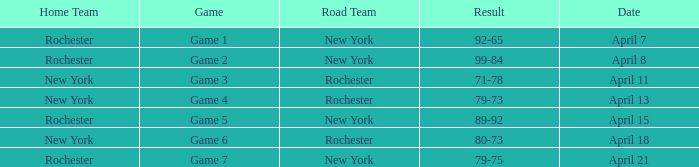Which Result has a Home Team of rochester, and a Game of game 5? 89-92. 